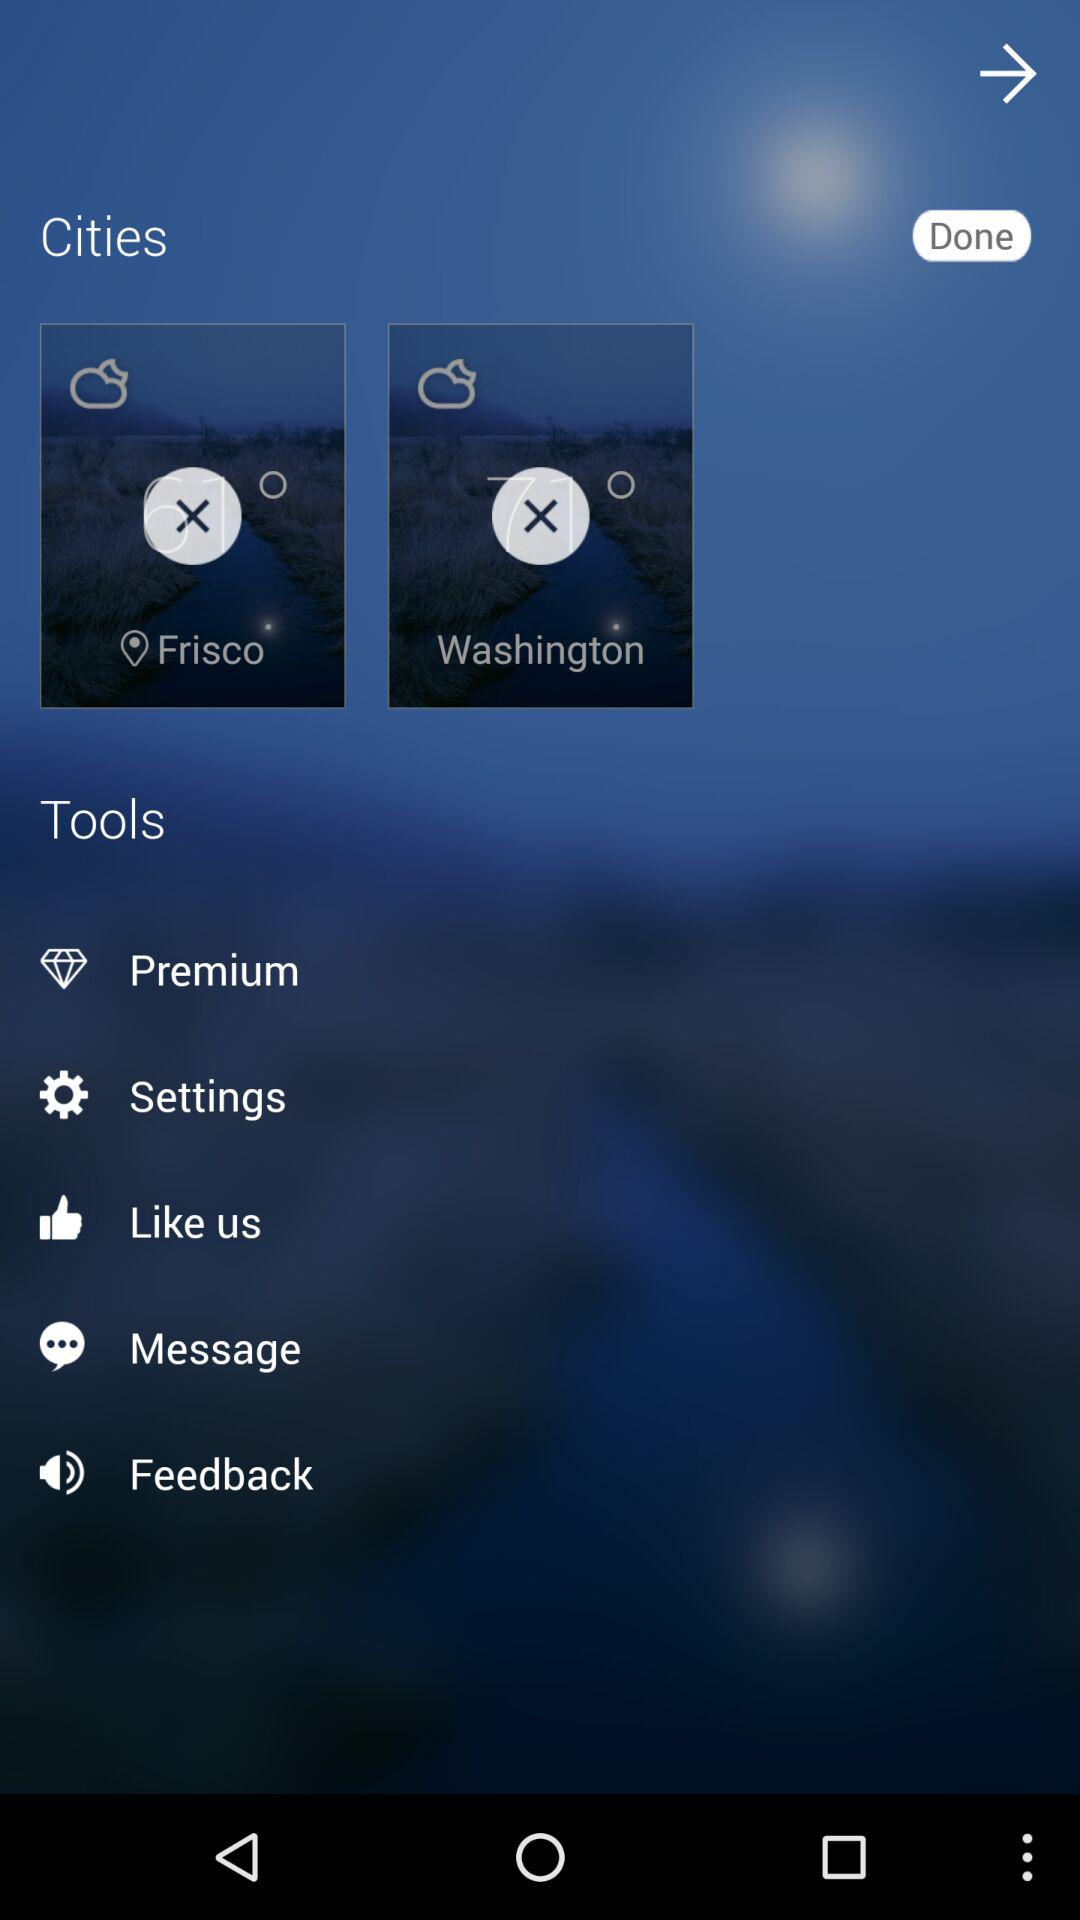What tools are listed? The listed tools are "Premium", "Settings", "Like us", "Message", and "Feedback". 